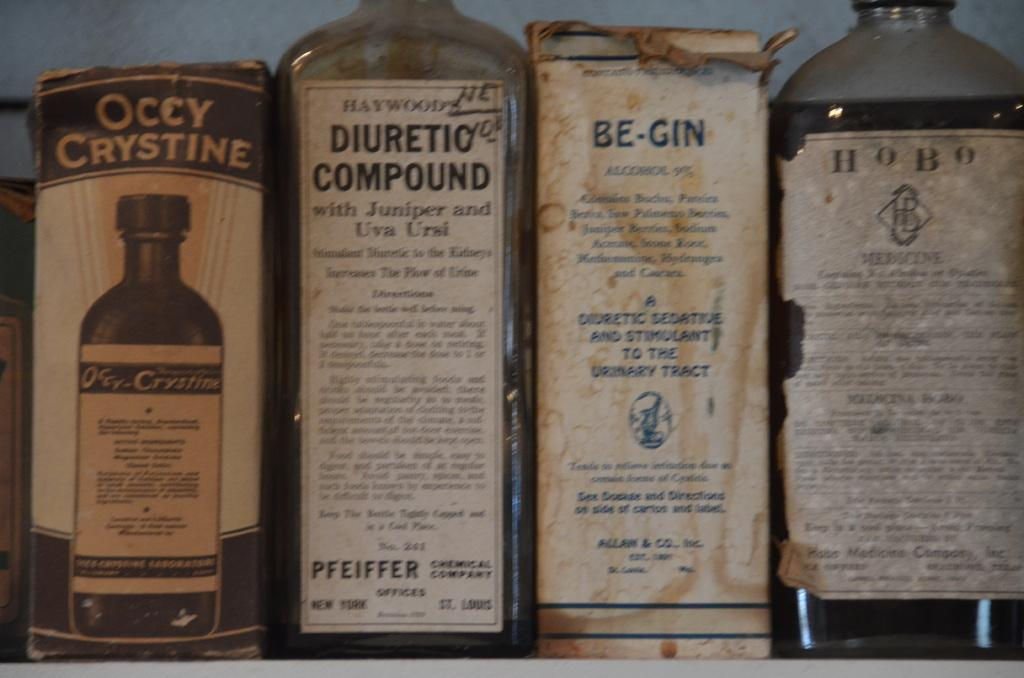<image>
Offer a succinct explanation of the picture presented. A row of old chemicals including Diuretic Compound. 